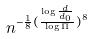Convert formula to latex. <formula><loc_0><loc_0><loc_500><loc_500>n ^ { - \frac { 1 } { 8 } ( \frac { \log \frac { d } { d _ { 0 } } } { \log \Pi } ) ^ { 8 } }</formula> 